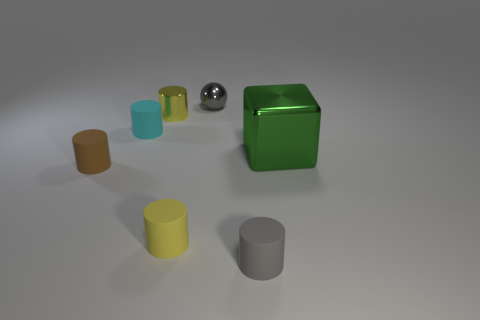The matte thing that is the same color as the metal cylinder is what shape?
Make the answer very short. Cylinder. The yellow object that is behind the small yellow object in front of the metal thing that is to the left of the gray metallic object is what shape?
Give a very brief answer. Cylinder. Are there an equal number of yellow metal cylinders behind the cyan matte object and green cubes?
Your answer should be compact. Yes. The thing that is the same color as the metallic cylinder is what size?
Your answer should be very brief. Small. Does the yellow matte thing have the same shape as the small cyan object?
Your response must be concise. Yes. How many things are tiny matte cylinders behind the gray rubber cylinder or small red shiny cubes?
Your answer should be very brief. 3. Is the number of small rubber cylinders that are on the left side of the tiny cyan matte thing the same as the number of green shiny cubes on the right side of the tiny sphere?
Ensure brevity in your answer.  Yes. What number of other things are the same shape as the yellow matte thing?
Offer a very short reply. 4. Does the yellow cylinder that is behind the big object have the same size as the gray thing that is to the left of the gray cylinder?
Provide a succinct answer. Yes. What number of cylinders are tiny yellow shiny things or rubber objects?
Give a very brief answer. 5. 